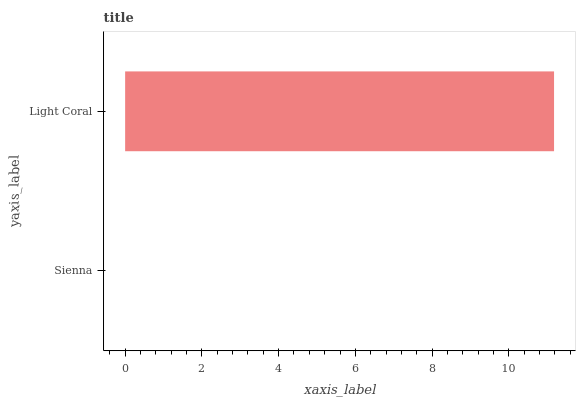Is Sienna the minimum?
Answer yes or no. Yes. Is Light Coral the maximum?
Answer yes or no. Yes. Is Light Coral the minimum?
Answer yes or no. No. Is Light Coral greater than Sienna?
Answer yes or no. Yes. Is Sienna less than Light Coral?
Answer yes or no. Yes. Is Sienna greater than Light Coral?
Answer yes or no. No. Is Light Coral less than Sienna?
Answer yes or no. No. Is Light Coral the high median?
Answer yes or no. Yes. Is Sienna the low median?
Answer yes or no. Yes. Is Sienna the high median?
Answer yes or no. No. Is Light Coral the low median?
Answer yes or no. No. 